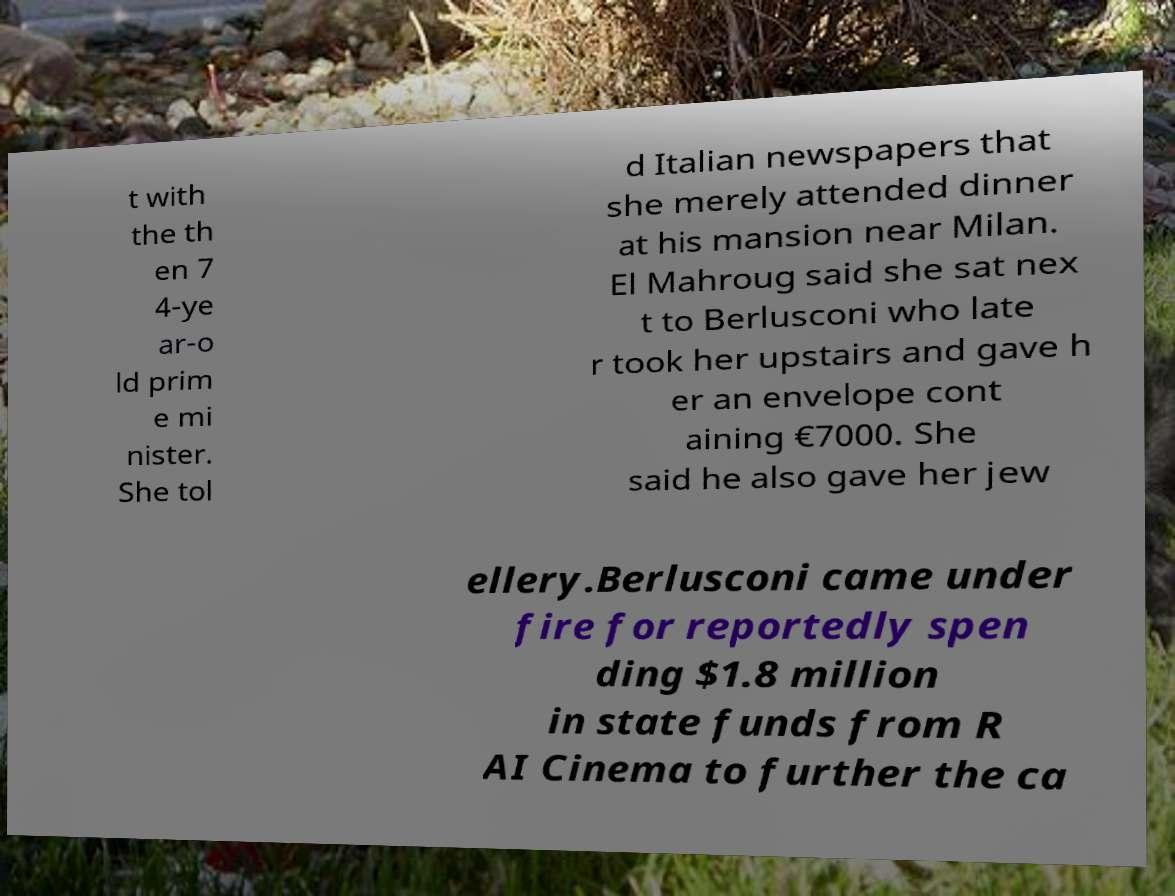Please identify and transcribe the text found in this image. t with the th en 7 4-ye ar-o ld prim e mi nister. She tol d Italian newspapers that she merely attended dinner at his mansion near Milan. El Mahroug said she sat nex t to Berlusconi who late r took her upstairs and gave h er an envelope cont aining €7000. She said he also gave her jew ellery.Berlusconi came under fire for reportedly spen ding $1.8 million in state funds from R AI Cinema to further the ca 